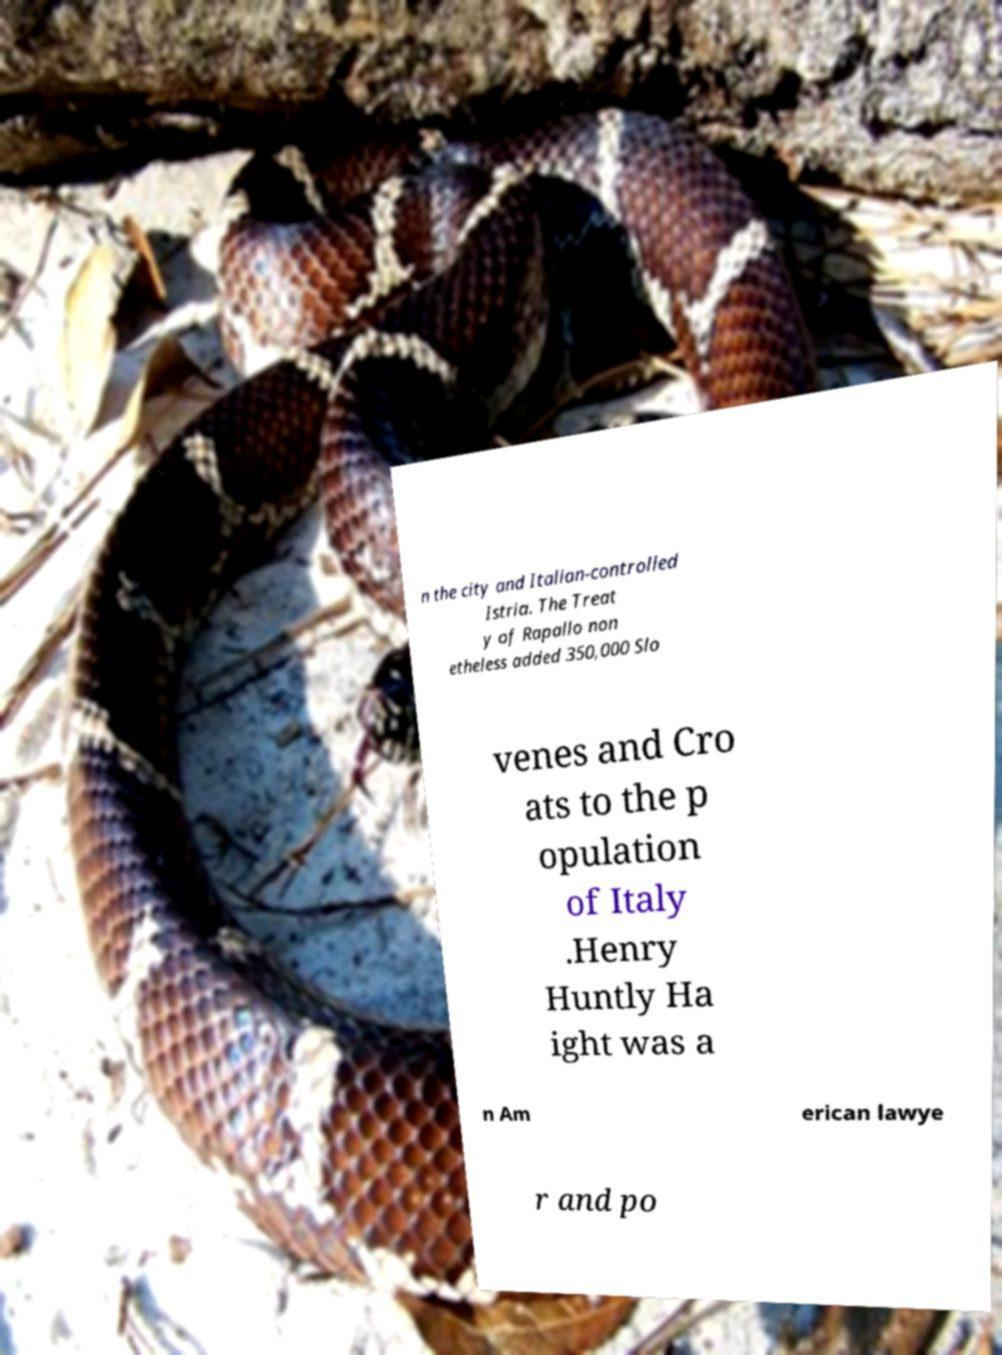Could you extract and type out the text from this image? n the city and Italian-controlled Istria. The Treat y of Rapallo non etheless added 350,000 Slo venes and Cro ats to the p opulation of Italy .Henry Huntly Ha ight was a n Am erican lawye r and po 